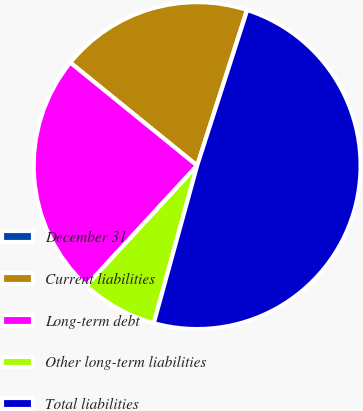<chart> <loc_0><loc_0><loc_500><loc_500><pie_chart><fcel>December 31<fcel>Current liabilities<fcel>Long-term debt<fcel>Other long-term liabilities<fcel>Total liabilities<nl><fcel>0.03%<fcel>19.07%<fcel>24.0%<fcel>7.58%<fcel>49.32%<nl></chart> 